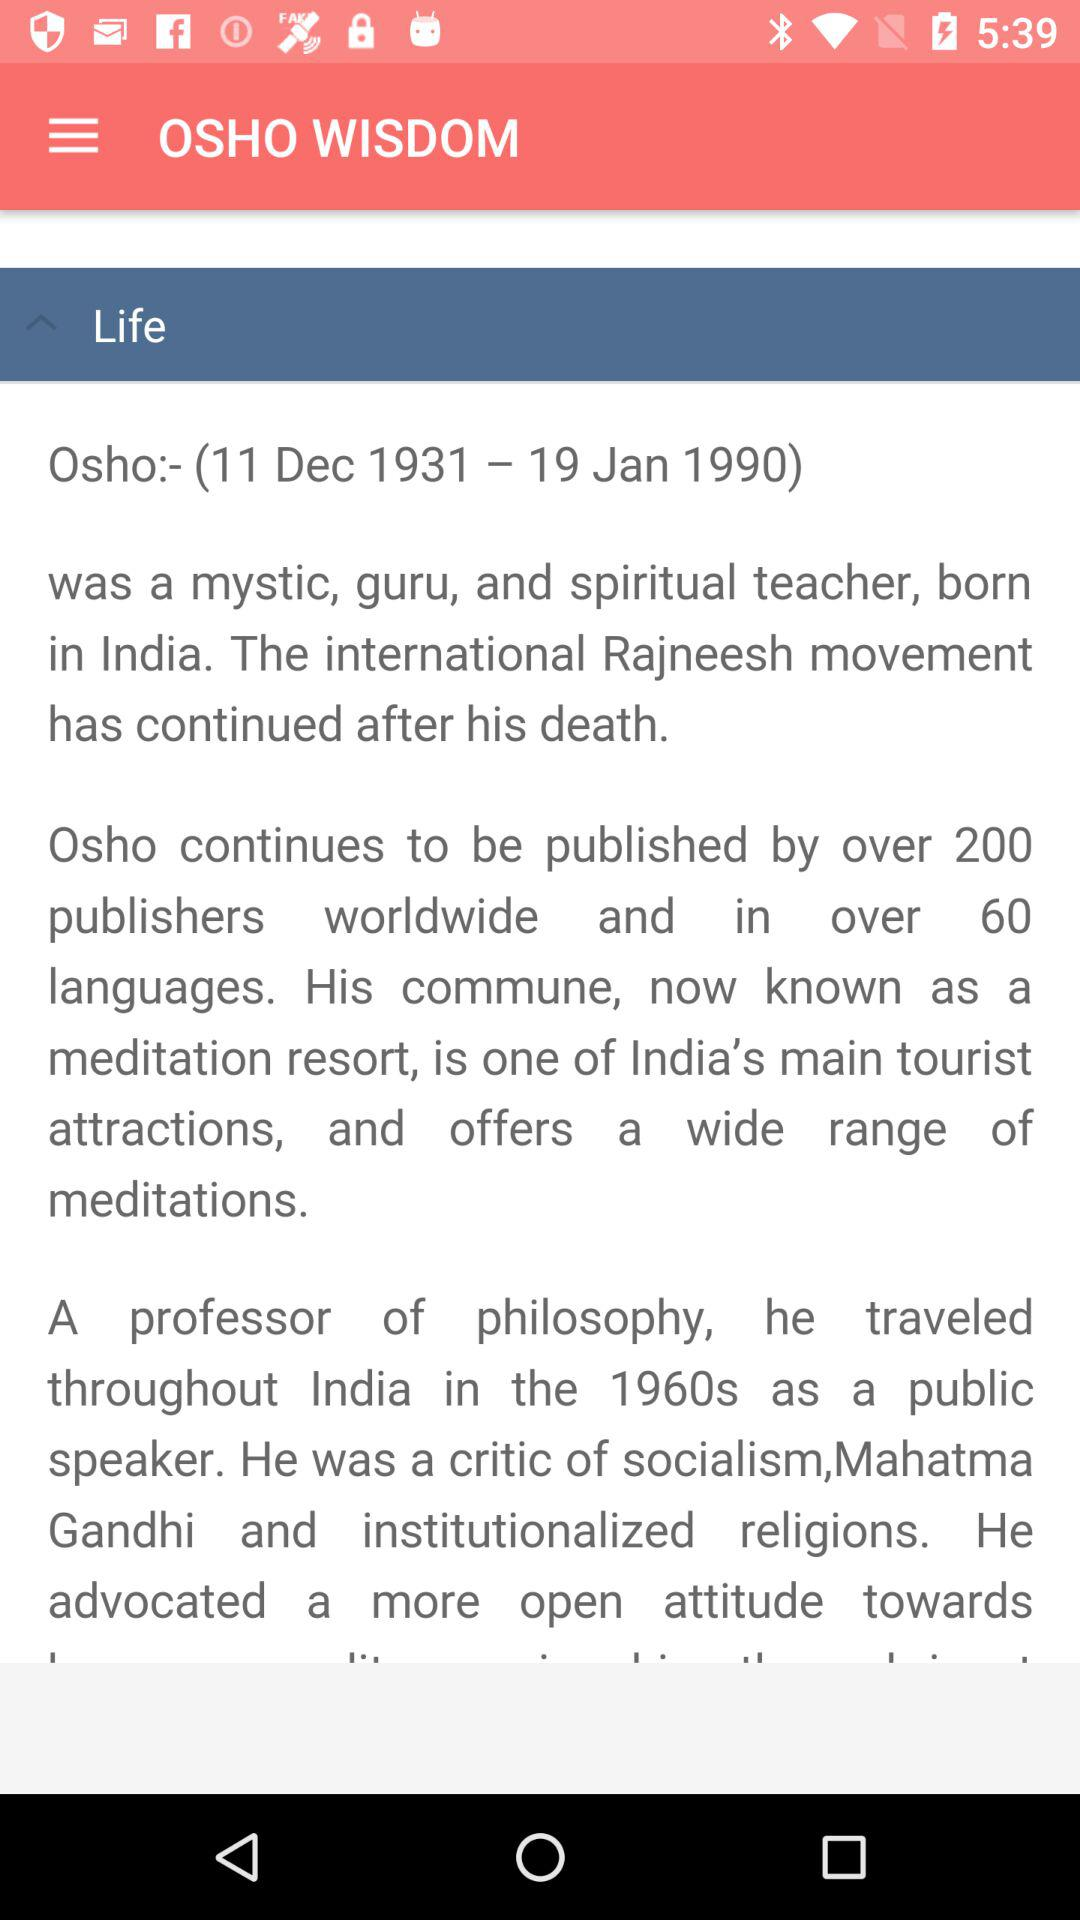What is the date of osho? The dates are 11 Dec 1931-19 Jan 1990. 